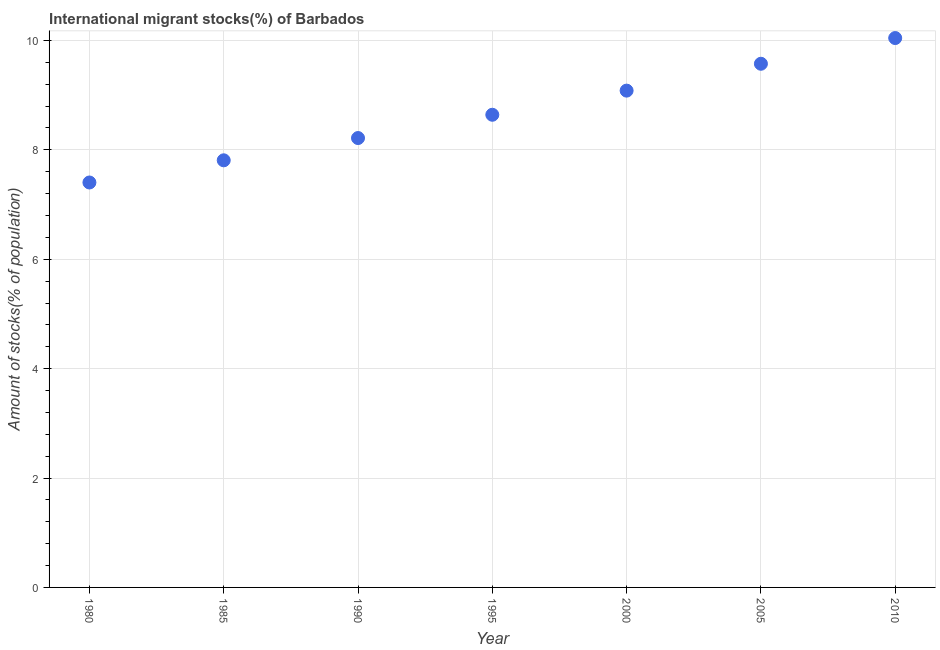What is the number of international migrant stocks in 1990?
Your answer should be very brief. 8.22. Across all years, what is the maximum number of international migrant stocks?
Give a very brief answer. 10.04. Across all years, what is the minimum number of international migrant stocks?
Keep it short and to the point. 7.4. In which year was the number of international migrant stocks minimum?
Provide a succinct answer. 1980. What is the sum of the number of international migrant stocks?
Ensure brevity in your answer.  60.77. What is the difference between the number of international migrant stocks in 1990 and 2005?
Ensure brevity in your answer.  -1.36. What is the average number of international migrant stocks per year?
Make the answer very short. 8.68. What is the median number of international migrant stocks?
Ensure brevity in your answer.  8.64. In how many years, is the number of international migrant stocks greater than 4.8 %?
Provide a succinct answer. 7. Do a majority of the years between 2010 and 1980 (inclusive) have number of international migrant stocks greater than 8.8 %?
Ensure brevity in your answer.  Yes. What is the ratio of the number of international migrant stocks in 1995 to that in 2010?
Your answer should be very brief. 0.86. Is the number of international migrant stocks in 1990 less than that in 2005?
Give a very brief answer. Yes. What is the difference between the highest and the second highest number of international migrant stocks?
Offer a very short reply. 0.47. Is the sum of the number of international migrant stocks in 1980 and 1990 greater than the maximum number of international migrant stocks across all years?
Make the answer very short. Yes. What is the difference between the highest and the lowest number of international migrant stocks?
Provide a short and direct response. 2.64. How many years are there in the graph?
Give a very brief answer. 7. What is the difference between two consecutive major ticks on the Y-axis?
Your answer should be very brief. 2. Are the values on the major ticks of Y-axis written in scientific E-notation?
Your answer should be compact. No. Does the graph contain any zero values?
Keep it short and to the point. No. Does the graph contain grids?
Offer a very short reply. Yes. What is the title of the graph?
Your response must be concise. International migrant stocks(%) of Barbados. What is the label or title of the Y-axis?
Provide a succinct answer. Amount of stocks(% of population). What is the Amount of stocks(% of population) in 1980?
Offer a very short reply. 7.4. What is the Amount of stocks(% of population) in 1985?
Your answer should be very brief. 7.81. What is the Amount of stocks(% of population) in 1990?
Your answer should be very brief. 8.22. What is the Amount of stocks(% of population) in 1995?
Your answer should be compact. 8.64. What is the Amount of stocks(% of population) in 2000?
Your answer should be very brief. 9.08. What is the Amount of stocks(% of population) in 2005?
Give a very brief answer. 9.57. What is the Amount of stocks(% of population) in 2010?
Keep it short and to the point. 10.04. What is the difference between the Amount of stocks(% of population) in 1980 and 1985?
Your answer should be compact. -0.41. What is the difference between the Amount of stocks(% of population) in 1980 and 1990?
Your response must be concise. -0.81. What is the difference between the Amount of stocks(% of population) in 1980 and 1995?
Your answer should be compact. -1.24. What is the difference between the Amount of stocks(% of population) in 1980 and 2000?
Your answer should be very brief. -1.68. What is the difference between the Amount of stocks(% of population) in 1980 and 2005?
Make the answer very short. -2.17. What is the difference between the Amount of stocks(% of population) in 1980 and 2010?
Keep it short and to the point. -2.64. What is the difference between the Amount of stocks(% of population) in 1985 and 1990?
Your response must be concise. -0.41. What is the difference between the Amount of stocks(% of population) in 1985 and 1995?
Your answer should be compact. -0.83. What is the difference between the Amount of stocks(% of population) in 1985 and 2000?
Your response must be concise. -1.27. What is the difference between the Amount of stocks(% of population) in 1985 and 2005?
Offer a very short reply. -1.77. What is the difference between the Amount of stocks(% of population) in 1985 and 2010?
Offer a terse response. -2.24. What is the difference between the Amount of stocks(% of population) in 1990 and 1995?
Your response must be concise. -0.43. What is the difference between the Amount of stocks(% of population) in 1990 and 2000?
Make the answer very short. -0.87. What is the difference between the Amount of stocks(% of population) in 1990 and 2005?
Your answer should be very brief. -1.36. What is the difference between the Amount of stocks(% of population) in 1990 and 2010?
Your response must be concise. -1.83. What is the difference between the Amount of stocks(% of population) in 1995 and 2000?
Provide a short and direct response. -0.44. What is the difference between the Amount of stocks(% of population) in 1995 and 2005?
Your response must be concise. -0.93. What is the difference between the Amount of stocks(% of population) in 1995 and 2010?
Keep it short and to the point. -1.4. What is the difference between the Amount of stocks(% of population) in 2000 and 2005?
Your response must be concise. -0.49. What is the difference between the Amount of stocks(% of population) in 2000 and 2010?
Provide a succinct answer. -0.96. What is the difference between the Amount of stocks(% of population) in 2005 and 2010?
Provide a succinct answer. -0.47. What is the ratio of the Amount of stocks(% of population) in 1980 to that in 1985?
Give a very brief answer. 0.95. What is the ratio of the Amount of stocks(% of population) in 1980 to that in 1990?
Provide a short and direct response. 0.9. What is the ratio of the Amount of stocks(% of population) in 1980 to that in 1995?
Your answer should be very brief. 0.86. What is the ratio of the Amount of stocks(% of population) in 1980 to that in 2000?
Your answer should be very brief. 0.81. What is the ratio of the Amount of stocks(% of population) in 1980 to that in 2005?
Provide a short and direct response. 0.77. What is the ratio of the Amount of stocks(% of population) in 1980 to that in 2010?
Offer a very short reply. 0.74. What is the ratio of the Amount of stocks(% of population) in 1985 to that in 1990?
Your answer should be compact. 0.95. What is the ratio of the Amount of stocks(% of population) in 1985 to that in 1995?
Provide a succinct answer. 0.9. What is the ratio of the Amount of stocks(% of population) in 1985 to that in 2000?
Provide a short and direct response. 0.86. What is the ratio of the Amount of stocks(% of population) in 1985 to that in 2005?
Your response must be concise. 0.82. What is the ratio of the Amount of stocks(% of population) in 1985 to that in 2010?
Your answer should be very brief. 0.78. What is the ratio of the Amount of stocks(% of population) in 1990 to that in 1995?
Ensure brevity in your answer.  0.95. What is the ratio of the Amount of stocks(% of population) in 1990 to that in 2000?
Keep it short and to the point. 0.91. What is the ratio of the Amount of stocks(% of population) in 1990 to that in 2005?
Your answer should be compact. 0.86. What is the ratio of the Amount of stocks(% of population) in 1990 to that in 2010?
Your answer should be compact. 0.82. What is the ratio of the Amount of stocks(% of population) in 1995 to that in 2000?
Provide a short and direct response. 0.95. What is the ratio of the Amount of stocks(% of population) in 1995 to that in 2005?
Keep it short and to the point. 0.9. What is the ratio of the Amount of stocks(% of population) in 1995 to that in 2010?
Ensure brevity in your answer.  0.86. What is the ratio of the Amount of stocks(% of population) in 2000 to that in 2005?
Make the answer very short. 0.95. What is the ratio of the Amount of stocks(% of population) in 2000 to that in 2010?
Provide a short and direct response. 0.9. What is the ratio of the Amount of stocks(% of population) in 2005 to that in 2010?
Ensure brevity in your answer.  0.95. 